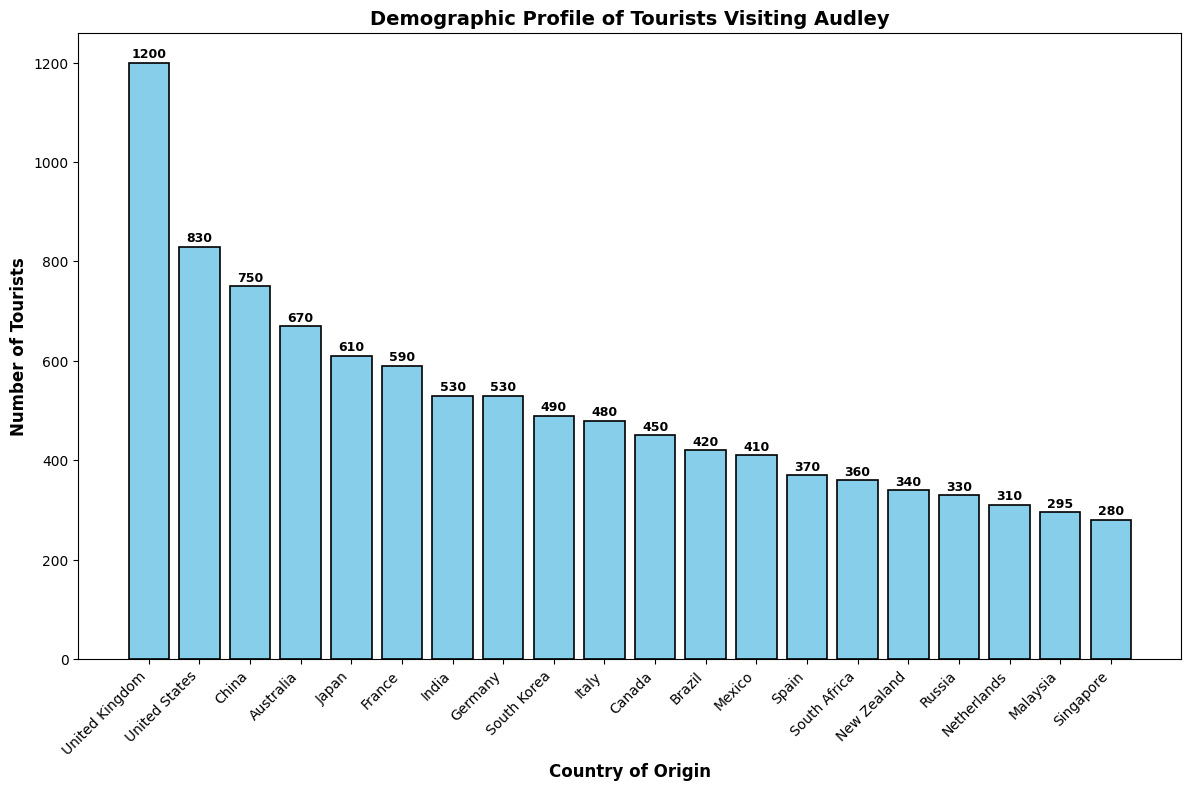What are the top three countries with the highest number of tourists visiting Audley? Refer to the bar chart values. The three tallest bars represent the United Kingdom (1200), the United States (830), and China (750) respectively. The height of the bars makes these countries stand out visually.
Answer: United Kingdom, United States, China Which country has more tourists visiting Audley, Germany or France? Compare the height of the bars for Germany and France. The bar for France reaches 590 while the bar for Germany stops at 530.
Answer: France How many more tourists are there from Australia compared to Brazil? Check the values for both Australia (670) and Brazil (420). Subtract Brazil's number from Australia's: 670 - 420.
Answer: 250 What is the total number of tourists from Italy, Spain, and Mexico combined? Add the number of tourists from Italy (480), Spain (370), and Mexico (410): 480 + 370 + 410.
Answer: 1260 Which country has the lowest number of tourists visiting Audley? Look for the shortest bar in the chart. Singapore has the shortest bar with 280 tourists.
Answer: Singapore What is the difference in the number of tourists between Japan and China? Look at the values for both Japan (610) and China (750). Subtract Japan's number from China's: 750 - 610.
Answer: 140 If we group the tourists from the United States and Canada together, how many tourists do we get? Add the number of tourists from the United States (830) and Canada (450): 830 + 450.
Answer: 1280 Are there more tourists from South Korea or from India visiting Audley? Compare the heights of the bars for South Korea and India. The bars show that India has 530 tourists while South Korea has 490.
Answer: India Which countries have more than 600 tourists each visiting Audley? Identify the bars taller than 600: United Kingdom (1200), United States (830), China (750), Australia (670), and Japan (610).
Answer: United Kingdom, United States, China, Australia, Japan How many countries have fewer than 400 tourists visiting Audley? Count the bars that represent fewer than 400 tourists. These are Spain (370), Russia (330), South Africa (360), New Zealand (340), Singapore (280), and Malaysia (295).
Answer: 6 